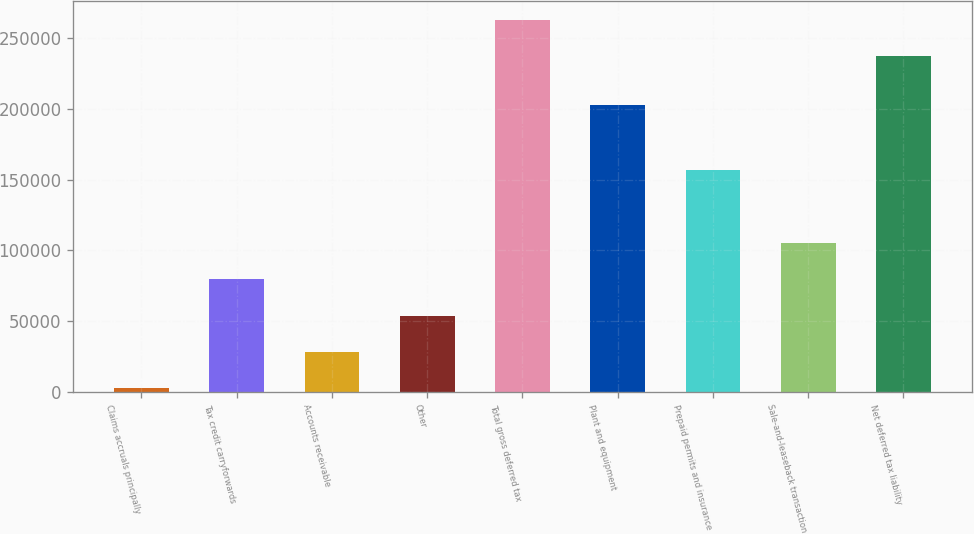<chart> <loc_0><loc_0><loc_500><loc_500><bar_chart><fcel>Claims accruals principally<fcel>Tax credit carryforwards<fcel>Accounts receivable<fcel>Other<fcel>Total gross deferred tax<fcel>Plant and equipment<fcel>Prepaid permits and insurance<fcel>Sale-and-leaseback transaction<fcel>Net deferred tax liability<nl><fcel>2198<fcel>79586.3<fcel>27994.1<fcel>53790.2<fcel>263289<fcel>202508<fcel>156975<fcel>105382<fcel>237493<nl></chart> 